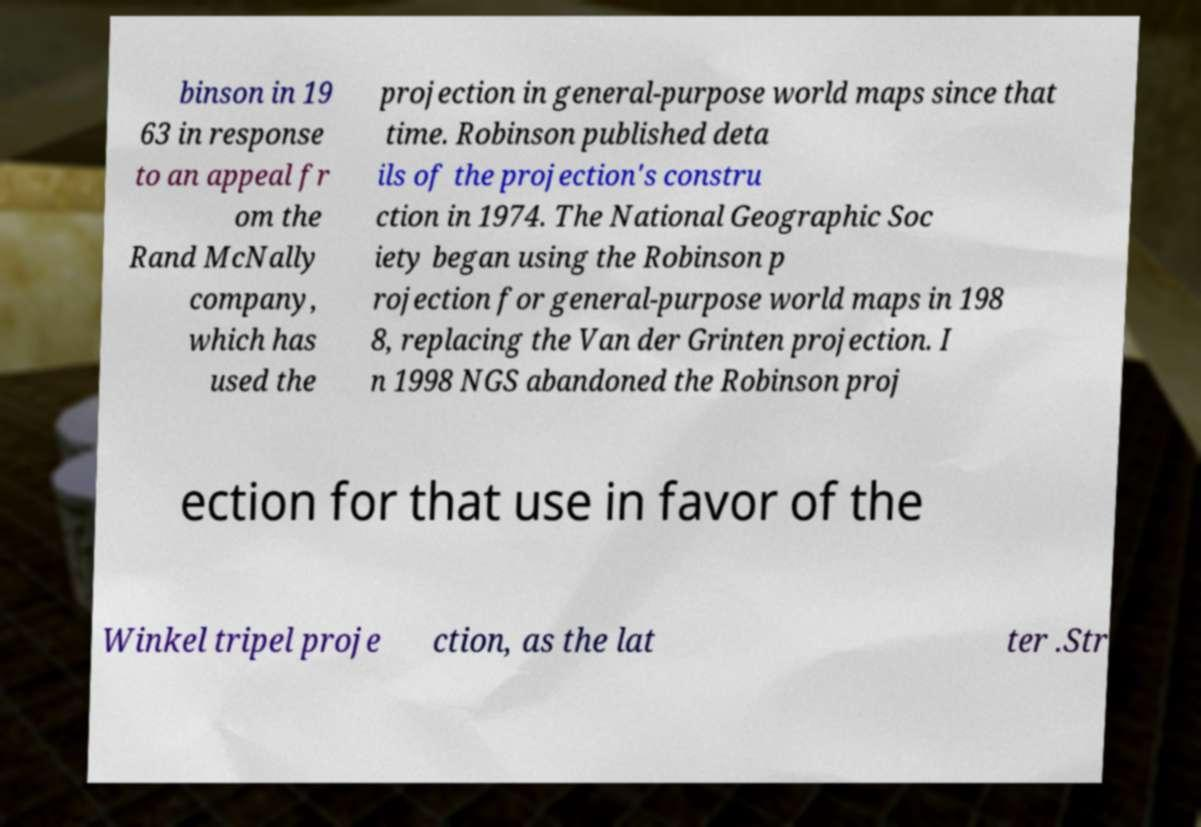What messages or text are displayed in this image? I need them in a readable, typed format. binson in 19 63 in response to an appeal fr om the Rand McNally company, which has used the projection in general-purpose world maps since that time. Robinson published deta ils of the projection's constru ction in 1974. The National Geographic Soc iety began using the Robinson p rojection for general-purpose world maps in 198 8, replacing the Van der Grinten projection. I n 1998 NGS abandoned the Robinson proj ection for that use in favor of the Winkel tripel proje ction, as the lat ter .Str 